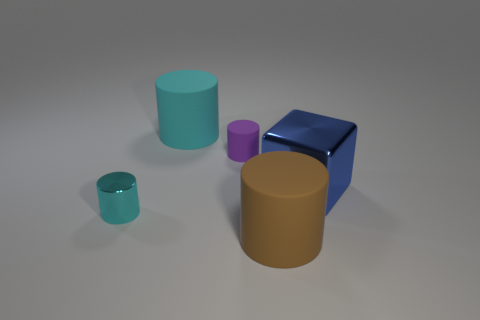Add 2 tiny purple shiny blocks. How many objects exist? 7 Subtract all cubes. How many objects are left? 4 Add 5 big cyan objects. How many big cyan objects are left? 6 Add 2 big blue metallic blocks. How many big blue metallic blocks exist? 3 Subtract 0 purple blocks. How many objects are left? 5 Subtract all small purple matte things. Subtract all large blue metallic cubes. How many objects are left? 3 